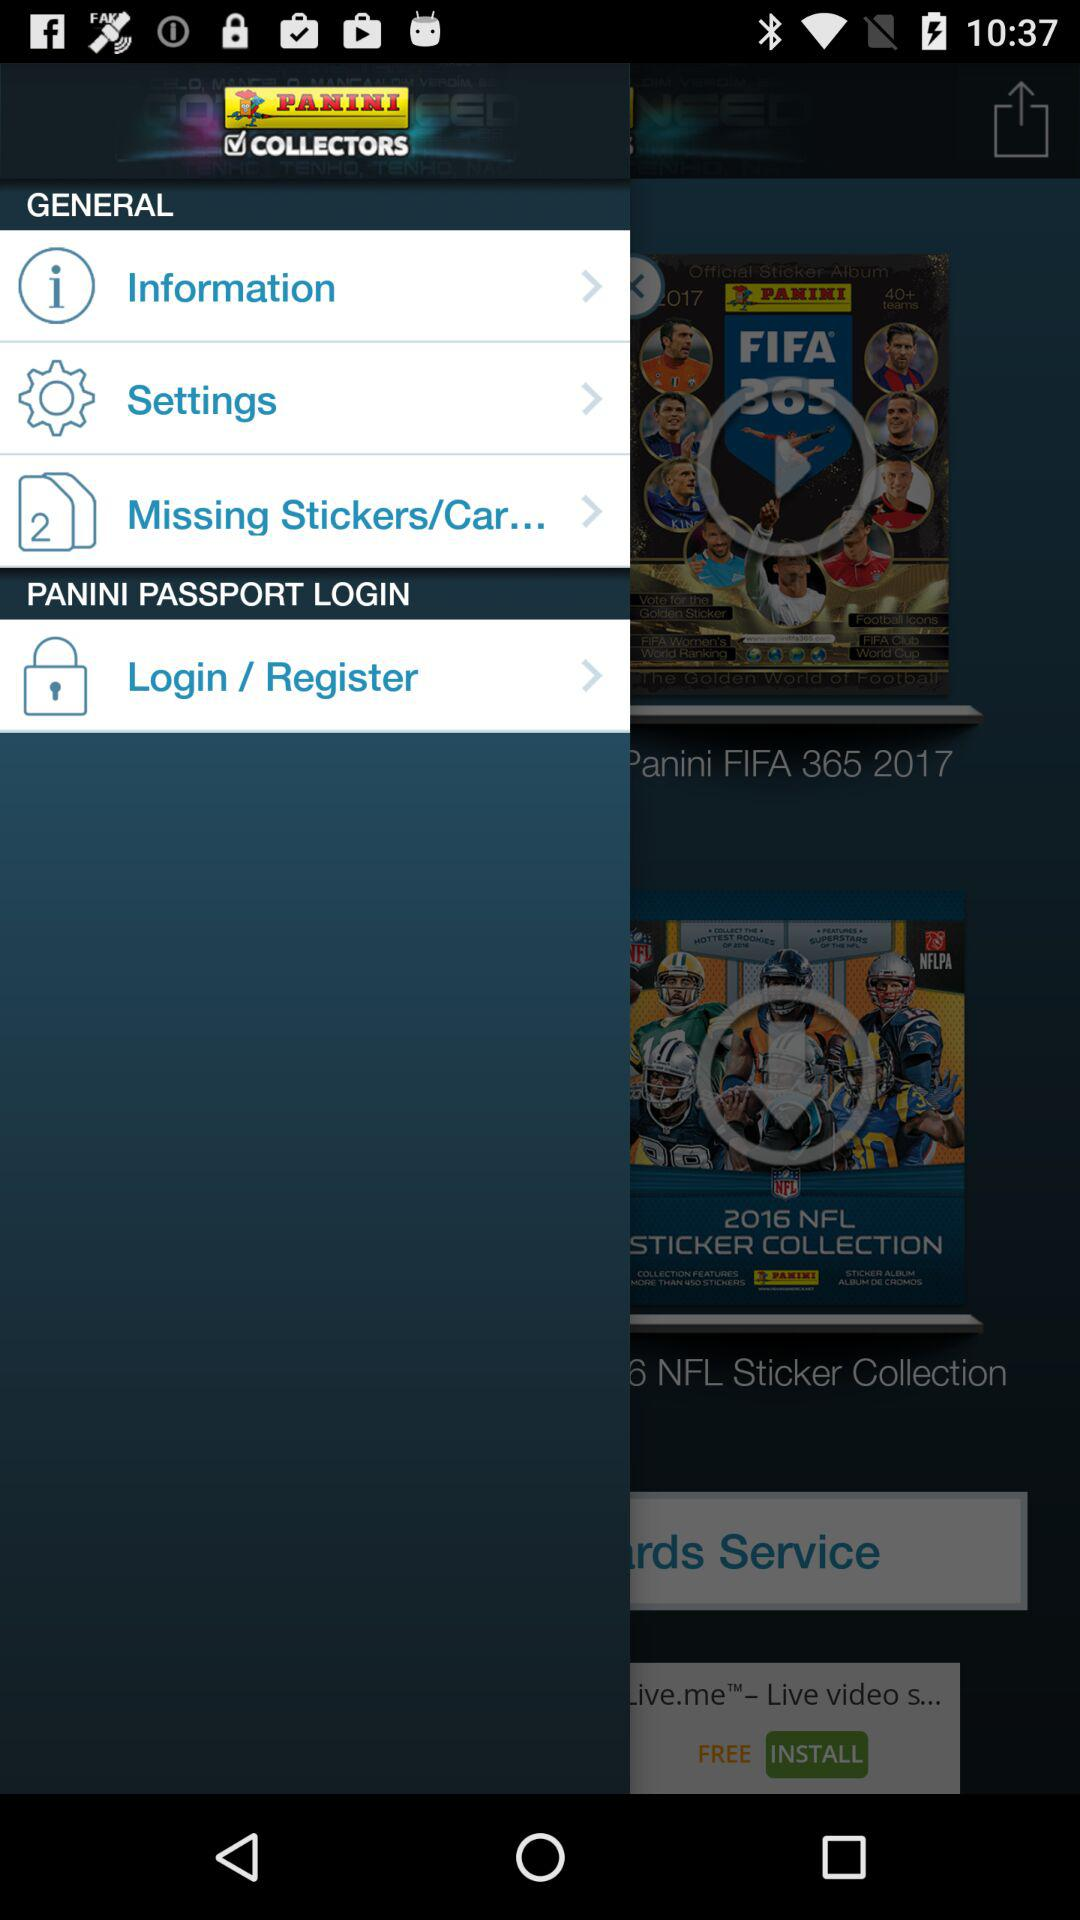What is the name of the application? The name of the application is "PANINI COLLECTORS". 